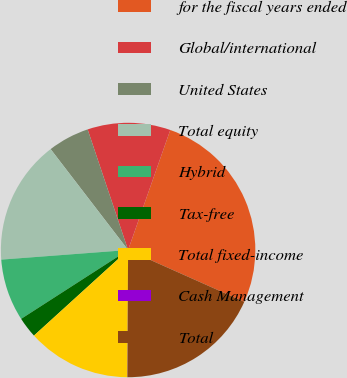<chart> <loc_0><loc_0><loc_500><loc_500><pie_chart><fcel>for the fiscal years ended<fcel>Global/international<fcel>United States<fcel>Total equity<fcel>Hybrid<fcel>Tax-free<fcel>Total fixed-income<fcel>Cash Management<fcel>Total<nl><fcel>26.3%<fcel>10.53%<fcel>5.27%<fcel>15.78%<fcel>7.9%<fcel>2.64%<fcel>13.16%<fcel>0.01%<fcel>18.41%<nl></chart> 